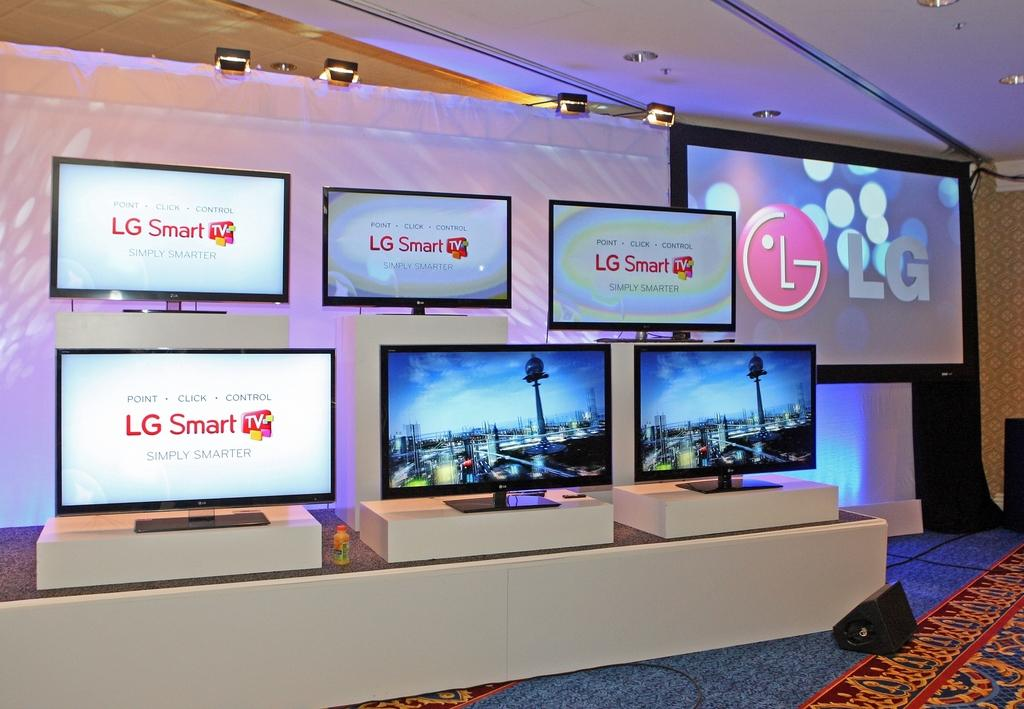<image>
Offer a succinct explanation of the picture presented. LG Smart TVs are lined up on display at an event. 